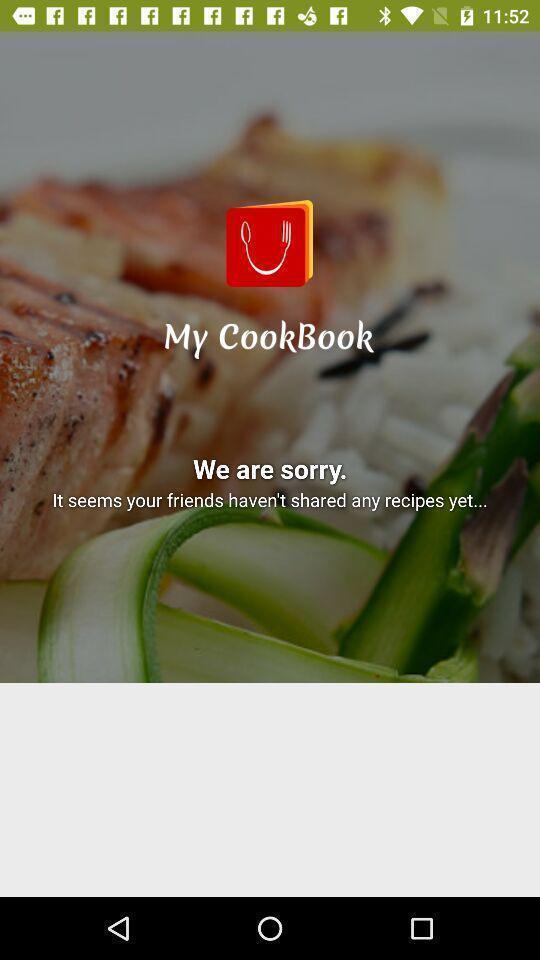Provide a description of this screenshot. Page displaying the results of searched recipe. 